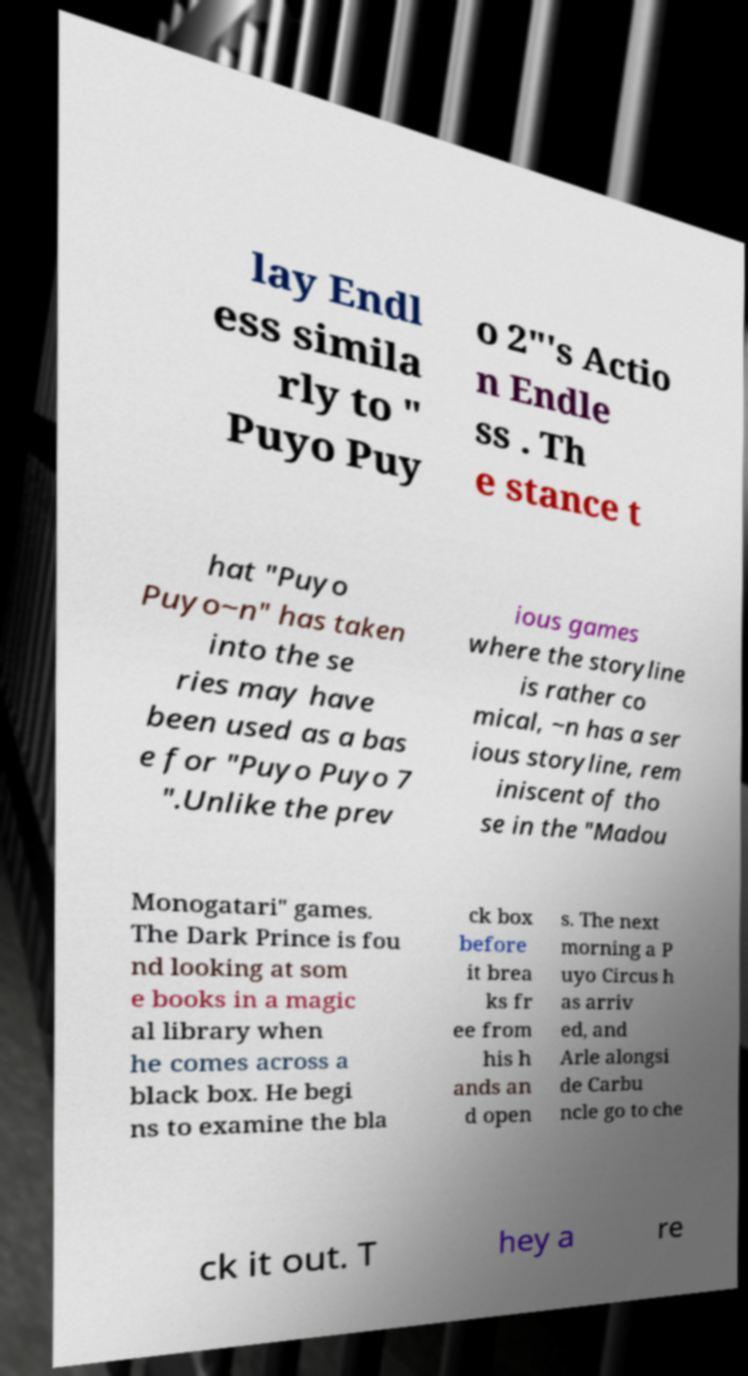For documentation purposes, I need the text within this image transcribed. Could you provide that? lay Endl ess simila rly to " Puyo Puy o 2"'s Actio n Endle ss . Th e stance t hat "Puyo Puyo~n" has taken into the se ries may have been used as a bas e for "Puyo Puyo 7 ".Unlike the prev ious games where the storyline is rather co mical, ~n has a ser ious storyline, rem iniscent of tho se in the "Madou Monogatari" games. The Dark Prince is fou nd looking at som e books in a magic al library when he comes across a black box. He begi ns to examine the bla ck box before it brea ks fr ee from his h ands an d open s. The next morning a P uyo Circus h as arriv ed, and Arle alongsi de Carbu ncle go to che ck it out. T hey a re 